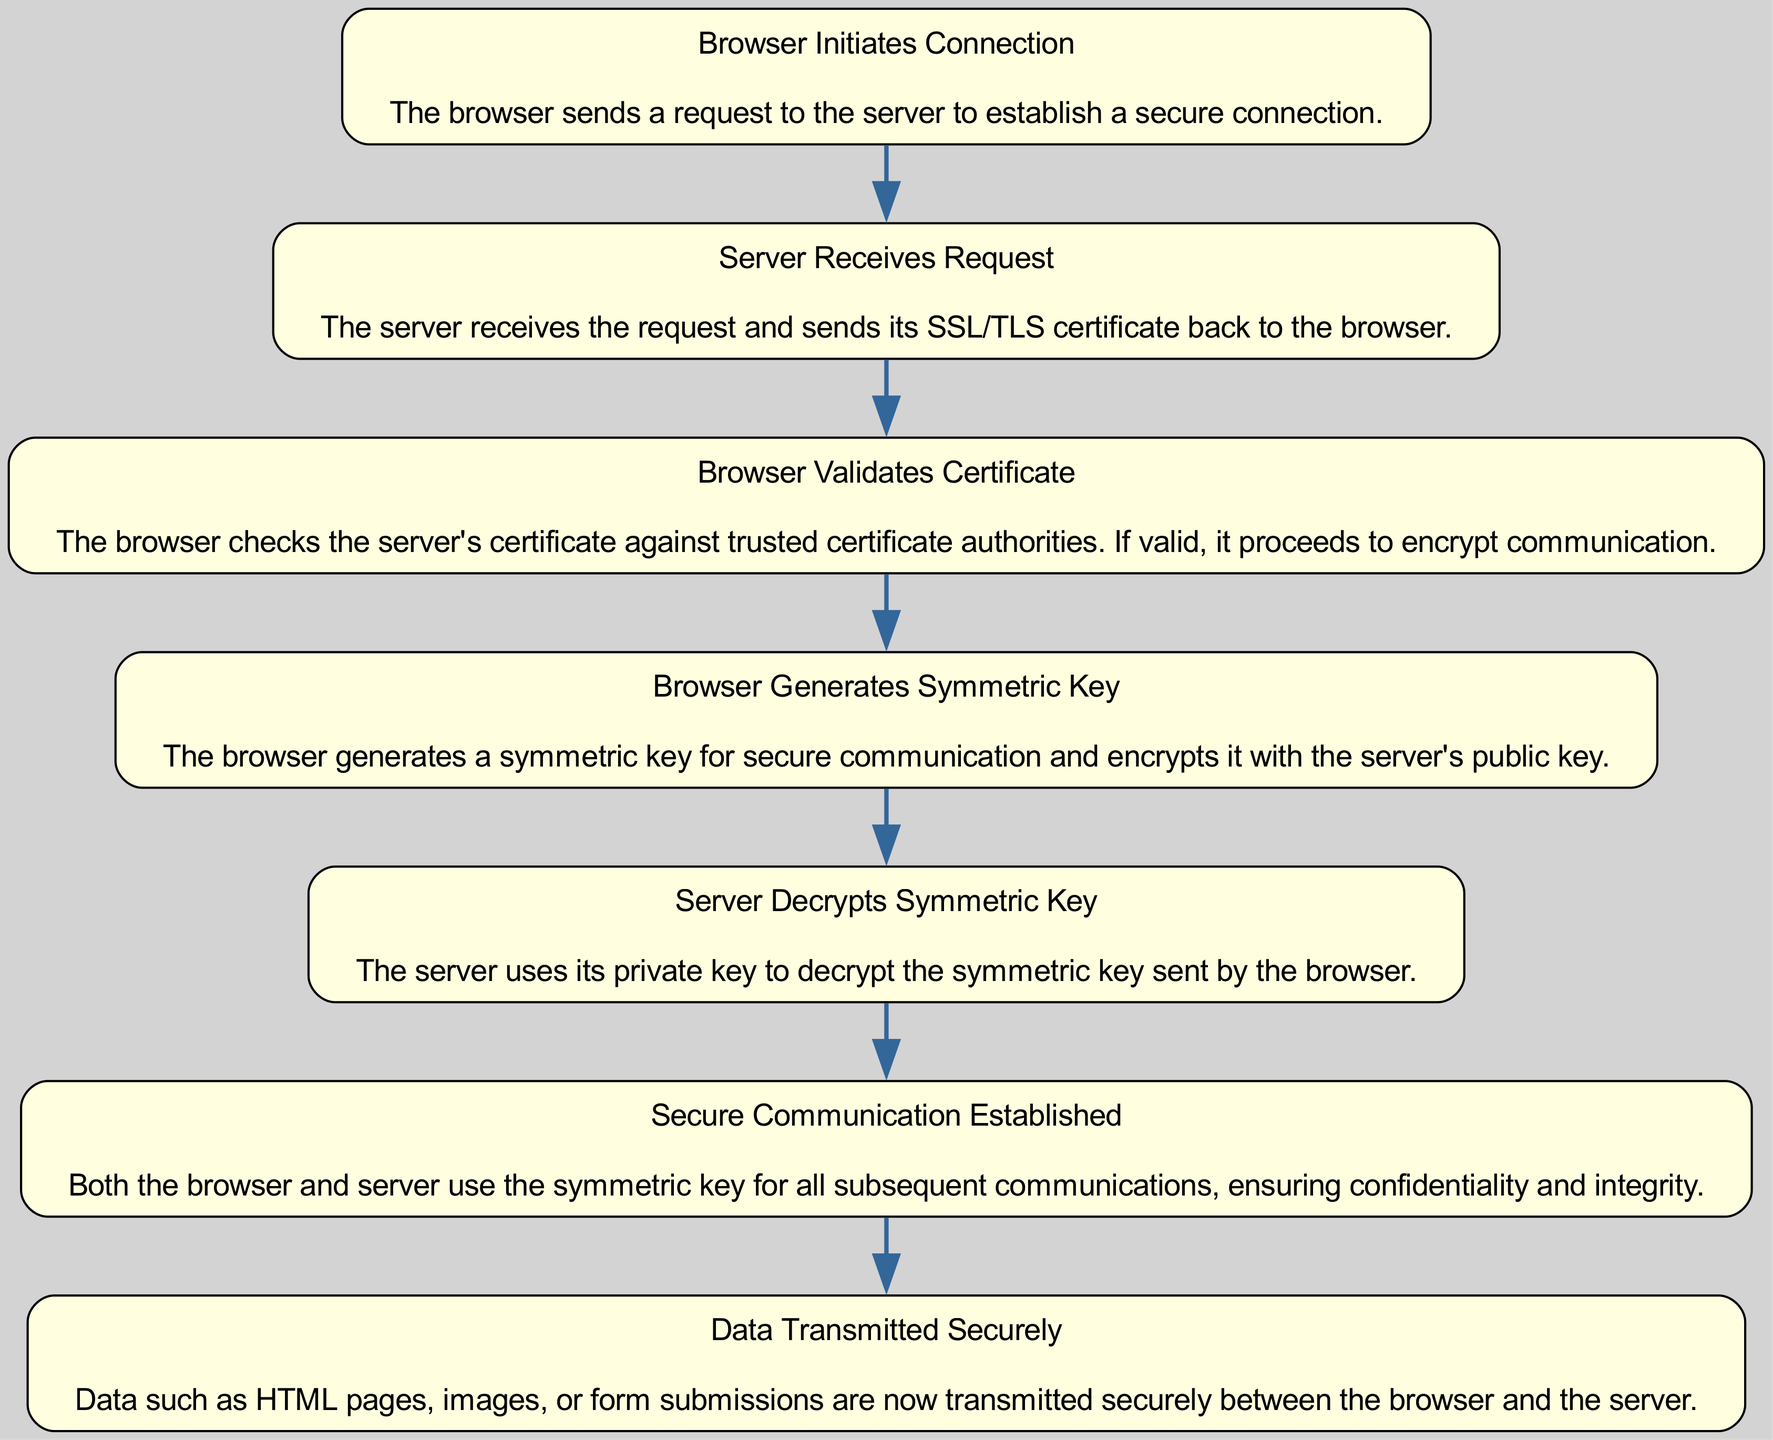What is the first step in the HTTPS connection lifecycle? The diagram starts with "Browser Initiates Connection," which indicates the first action taken in the secure connection process, where the browser sends a request to the server.
Answer: Browser Initiates Connection How many nodes are present in the diagram? By counting the individual elements listed in the diagram, there are a total of seven unique nodes representing different stages of the HTTPS connection lifecycle.
Answer: 7 What follows after "Server Receives Request"? From the flow of the diagram, it is clear that after "Server Receives Request," the next step is for the "Browser Validates Certificate," making it a direct connection in the sequence.
Answer: Browser Validates Certificate What is the end stage of the secure communication process? The last node in the diagram is "Data Transmitted Securely," indicating that secure data transfer is the final goal of establishing the HTTPS connection.
Answer: Data Transmitted Securely Which item is involved in both generating and encrypting a symmetric key? The node "Browser Generates Symmetric Key" is responsible for both creating the symmetric key and encrypting it with the server's public key, thus linking these two important roles in the lifecycle process.
Answer: Browser Generates Symmetric Key What is the main action performed by the server after it receives the symmetric key? According to the diagram, after the server receives the symmetric key, it proceeds to "Server Decrypts Symmetric Key," which is the immediate action that follows for secure communication setup.
Answer: Server Decrypts Symmetric Key What ensures confidentiality and integrity in the communication process? The node "Secure Communication Established" signifies that once this stage is reached, both the browser and the server use the symmetric key, which plays a crucial role in safeguarding confidentiality and integrity throughout their interactions.
Answer: Secure Communication Established How does the browser verify the server's certificate? The process indicates that "Browser Validates Certificate" involves checking the server's certificate against trusted certificate authorities to ensure it is legitimate before proceeding with the connection.
Answer: Trusted certificate authorities 